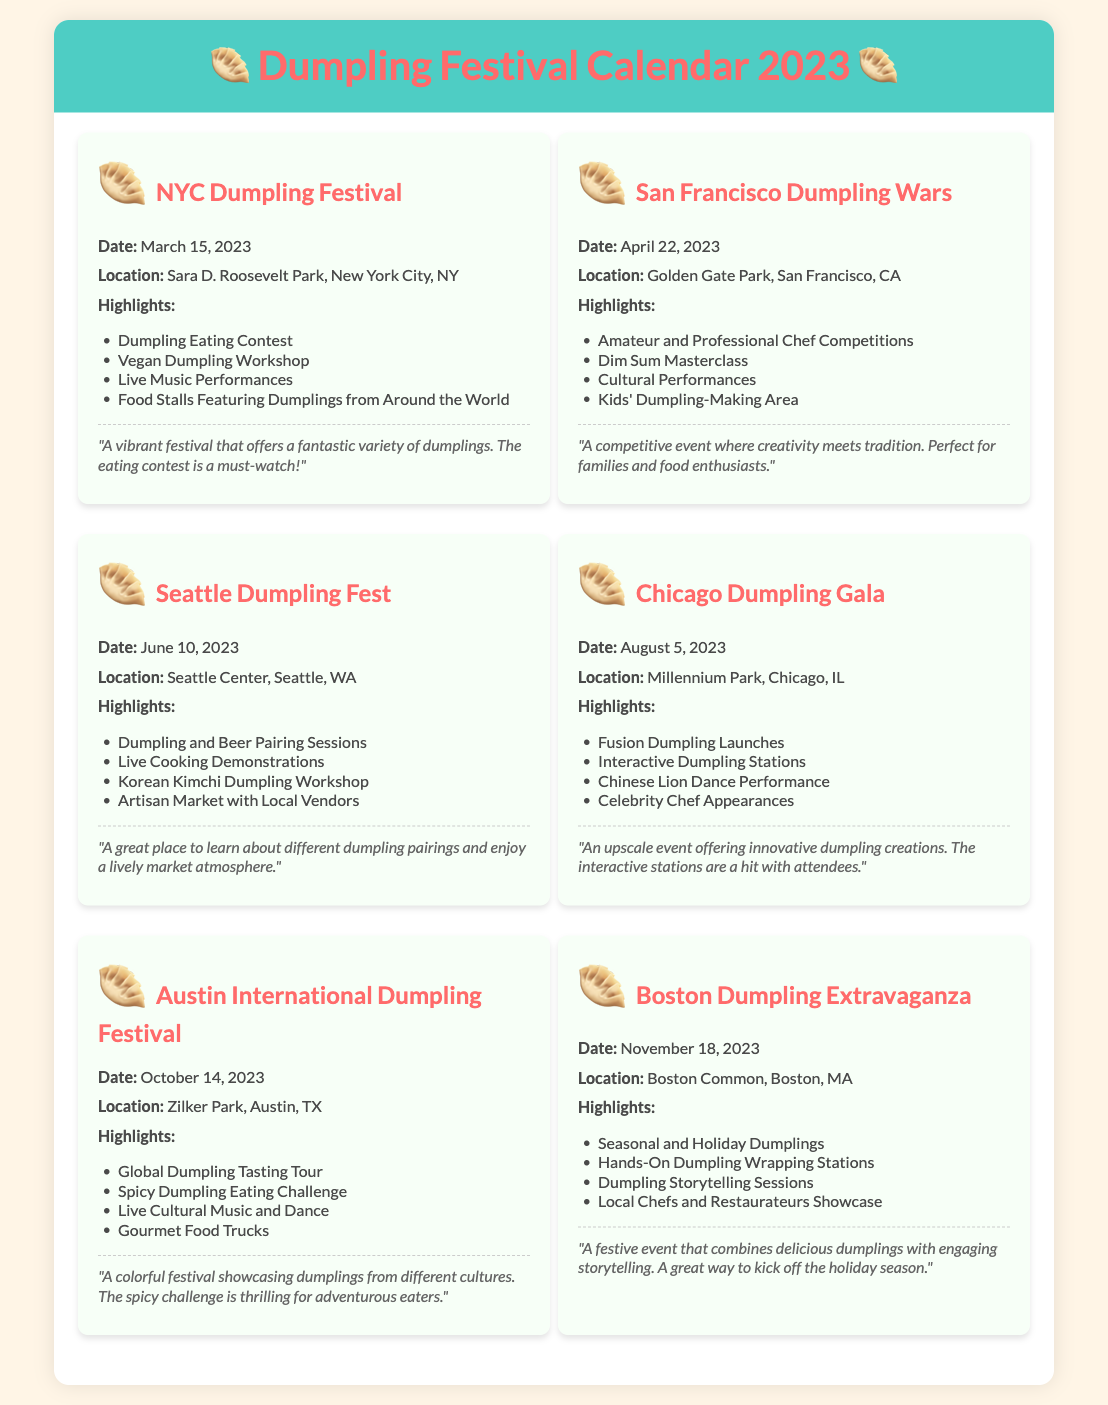What is the date of the NYC Dumpling Festival? The NYC Dumpling Festival takes place on March 15, 2023.
Answer: March 15, 2023 What location hosts the San Francisco Dumpling Wars? The San Francisco Dumpling Wars is held at Golden Gate Park, San Francisco, CA.
Answer: Golden Gate Park, San Francisco, CA What is one highlight of the Seattle Dumpling Fest? One highlight of the Seattle Dumpling Fest is the Dumpling and Beer Pairing Sessions.
Answer: Dumpling and Beer Pairing Sessions How many events are listed in the calendar? There are a total of six events listed in the document.
Answer: Six What type of performance is featured in the Chicago Dumpling Gala? The Chicago Dumpling Gala features a Chinese Lion Dance Performance.
Answer: Chinese Lion Dance Performance What is the unique challenge at the Austin International Dumpling Festival? The Austin International Dumpling Festival features a Spicy Dumpling Eating Challenge.
Answer: Spicy Dumpling Eating Challenge Which festival includes hands-on dumpling wrapping stations? The Boston Dumpling Extravaganza includes hands-on dumpling wrapping stations.
Answer: Boston Dumpling Extravaganza What type of culinary session is offered at the San Francisco Dumpling Wars? The San Francisco Dumpling Wars offers a Dim Sum Masterclass.
Answer: Dim Sum Masterclass Which festival is described as a colorful festival showcasing dumplings from different cultures? The Austin International Dumpling Festival is described in that way.
Answer: Austin International Dumpling Festival 